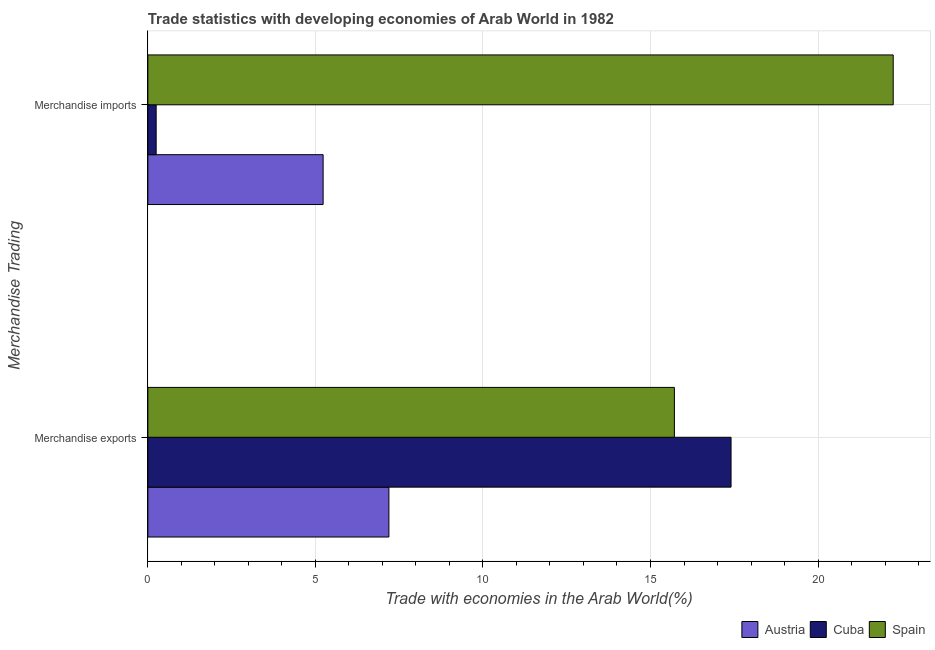Are the number of bars per tick equal to the number of legend labels?
Your response must be concise. Yes. Are the number of bars on each tick of the Y-axis equal?
Give a very brief answer. Yes. How many bars are there on the 2nd tick from the top?
Offer a very short reply. 3. How many bars are there on the 1st tick from the bottom?
Your answer should be very brief. 3. What is the merchandise imports in Spain?
Your answer should be very brief. 22.24. Across all countries, what is the maximum merchandise imports?
Give a very brief answer. 22.24. Across all countries, what is the minimum merchandise imports?
Keep it short and to the point. 0.25. In which country was the merchandise imports maximum?
Your answer should be very brief. Spain. In which country was the merchandise imports minimum?
Your answer should be very brief. Cuba. What is the total merchandise imports in the graph?
Offer a very short reply. 27.72. What is the difference between the merchandise imports in Cuba and that in Austria?
Keep it short and to the point. -4.98. What is the difference between the merchandise exports in Austria and the merchandise imports in Cuba?
Keep it short and to the point. 6.95. What is the average merchandise exports per country?
Provide a short and direct response. 13.44. What is the difference between the merchandise exports and merchandise imports in Cuba?
Offer a terse response. 17.16. In how many countries, is the merchandise imports greater than 22 %?
Make the answer very short. 1. What is the ratio of the merchandise exports in Spain to that in Austria?
Provide a short and direct response. 2.18. Is the merchandise exports in Austria less than that in Spain?
Provide a succinct answer. Yes. How many bars are there?
Provide a short and direct response. 6. Are all the bars in the graph horizontal?
Give a very brief answer. Yes. Are the values on the major ticks of X-axis written in scientific E-notation?
Keep it short and to the point. No. Does the graph contain grids?
Make the answer very short. Yes. Where does the legend appear in the graph?
Offer a very short reply. Bottom right. What is the title of the graph?
Provide a short and direct response. Trade statistics with developing economies of Arab World in 1982. What is the label or title of the X-axis?
Give a very brief answer. Trade with economies in the Arab World(%). What is the label or title of the Y-axis?
Keep it short and to the point. Merchandise Trading. What is the Trade with economies in the Arab World(%) in Austria in Merchandise exports?
Ensure brevity in your answer.  7.19. What is the Trade with economies in the Arab World(%) of Cuba in Merchandise exports?
Your answer should be compact. 17.4. What is the Trade with economies in the Arab World(%) in Spain in Merchandise exports?
Offer a terse response. 15.71. What is the Trade with economies in the Arab World(%) of Austria in Merchandise imports?
Give a very brief answer. 5.23. What is the Trade with economies in the Arab World(%) of Cuba in Merchandise imports?
Keep it short and to the point. 0.25. What is the Trade with economies in the Arab World(%) of Spain in Merchandise imports?
Offer a terse response. 22.24. Across all Merchandise Trading, what is the maximum Trade with economies in the Arab World(%) in Austria?
Offer a very short reply. 7.19. Across all Merchandise Trading, what is the maximum Trade with economies in the Arab World(%) in Cuba?
Provide a succinct answer. 17.4. Across all Merchandise Trading, what is the maximum Trade with economies in the Arab World(%) of Spain?
Provide a short and direct response. 22.24. Across all Merchandise Trading, what is the minimum Trade with economies in the Arab World(%) in Austria?
Your answer should be very brief. 5.23. Across all Merchandise Trading, what is the minimum Trade with economies in the Arab World(%) of Cuba?
Provide a short and direct response. 0.25. Across all Merchandise Trading, what is the minimum Trade with economies in the Arab World(%) in Spain?
Offer a terse response. 15.71. What is the total Trade with economies in the Arab World(%) in Austria in the graph?
Provide a succinct answer. 12.42. What is the total Trade with economies in the Arab World(%) of Cuba in the graph?
Offer a very short reply. 17.65. What is the total Trade with economies in the Arab World(%) in Spain in the graph?
Ensure brevity in your answer.  37.96. What is the difference between the Trade with economies in the Arab World(%) of Austria in Merchandise exports and that in Merchandise imports?
Keep it short and to the point. 1.96. What is the difference between the Trade with economies in the Arab World(%) in Cuba in Merchandise exports and that in Merchandise imports?
Provide a short and direct response. 17.16. What is the difference between the Trade with economies in the Arab World(%) in Spain in Merchandise exports and that in Merchandise imports?
Provide a short and direct response. -6.53. What is the difference between the Trade with economies in the Arab World(%) of Austria in Merchandise exports and the Trade with economies in the Arab World(%) of Cuba in Merchandise imports?
Your answer should be compact. 6.95. What is the difference between the Trade with economies in the Arab World(%) in Austria in Merchandise exports and the Trade with economies in the Arab World(%) in Spain in Merchandise imports?
Offer a very short reply. -15.05. What is the difference between the Trade with economies in the Arab World(%) in Cuba in Merchandise exports and the Trade with economies in the Arab World(%) in Spain in Merchandise imports?
Keep it short and to the point. -4.84. What is the average Trade with economies in the Arab World(%) in Austria per Merchandise Trading?
Make the answer very short. 6.21. What is the average Trade with economies in the Arab World(%) of Cuba per Merchandise Trading?
Provide a short and direct response. 8.83. What is the average Trade with economies in the Arab World(%) in Spain per Merchandise Trading?
Offer a very short reply. 18.98. What is the difference between the Trade with economies in the Arab World(%) in Austria and Trade with economies in the Arab World(%) in Cuba in Merchandise exports?
Ensure brevity in your answer.  -10.21. What is the difference between the Trade with economies in the Arab World(%) of Austria and Trade with economies in the Arab World(%) of Spain in Merchandise exports?
Provide a short and direct response. -8.52. What is the difference between the Trade with economies in the Arab World(%) in Cuba and Trade with economies in the Arab World(%) in Spain in Merchandise exports?
Provide a succinct answer. 1.69. What is the difference between the Trade with economies in the Arab World(%) of Austria and Trade with economies in the Arab World(%) of Cuba in Merchandise imports?
Provide a succinct answer. 4.98. What is the difference between the Trade with economies in the Arab World(%) in Austria and Trade with economies in the Arab World(%) in Spain in Merchandise imports?
Your response must be concise. -17.01. What is the difference between the Trade with economies in the Arab World(%) in Cuba and Trade with economies in the Arab World(%) in Spain in Merchandise imports?
Your answer should be very brief. -22. What is the ratio of the Trade with economies in the Arab World(%) of Austria in Merchandise exports to that in Merchandise imports?
Provide a succinct answer. 1.38. What is the ratio of the Trade with economies in the Arab World(%) in Cuba in Merchandise exports to that in Merchandise imports?
Provide a short and direct response. 70.4. What is the ratio of the Trade with economies in the Arab World(%) in Spain in Merchandise exports to that in Merchandise imports?
Give a very brief answer. 0.71. What is the difference between the highest and the second highest Trade with economies in the Arab World(%) in Austria?
Keep it short and to the point. 1.96. What is the difference between the highest and the second highest Trade with economies in the Arab World(%) in Cuba?
Provide a succinct answer. 17.16. What is the difference between the highest and the second highest Trade with economies in the Arab World(%) of Spain?
Make the answer very short. 6.53. What is the difference between the highest and the lowest Trade with economies in the Arab World(%) in Austria?
Your response must be concise. 1.96. What is the difference between the highest and the lowest Trade with economies in the Arab World(%) in Cuba?
Your response must be concise. 17.16. What is the difference between the highest and the lowest Trade with economies in the Arab World(%) of Spain?
Ensure brevity in your answer.  6.53. 